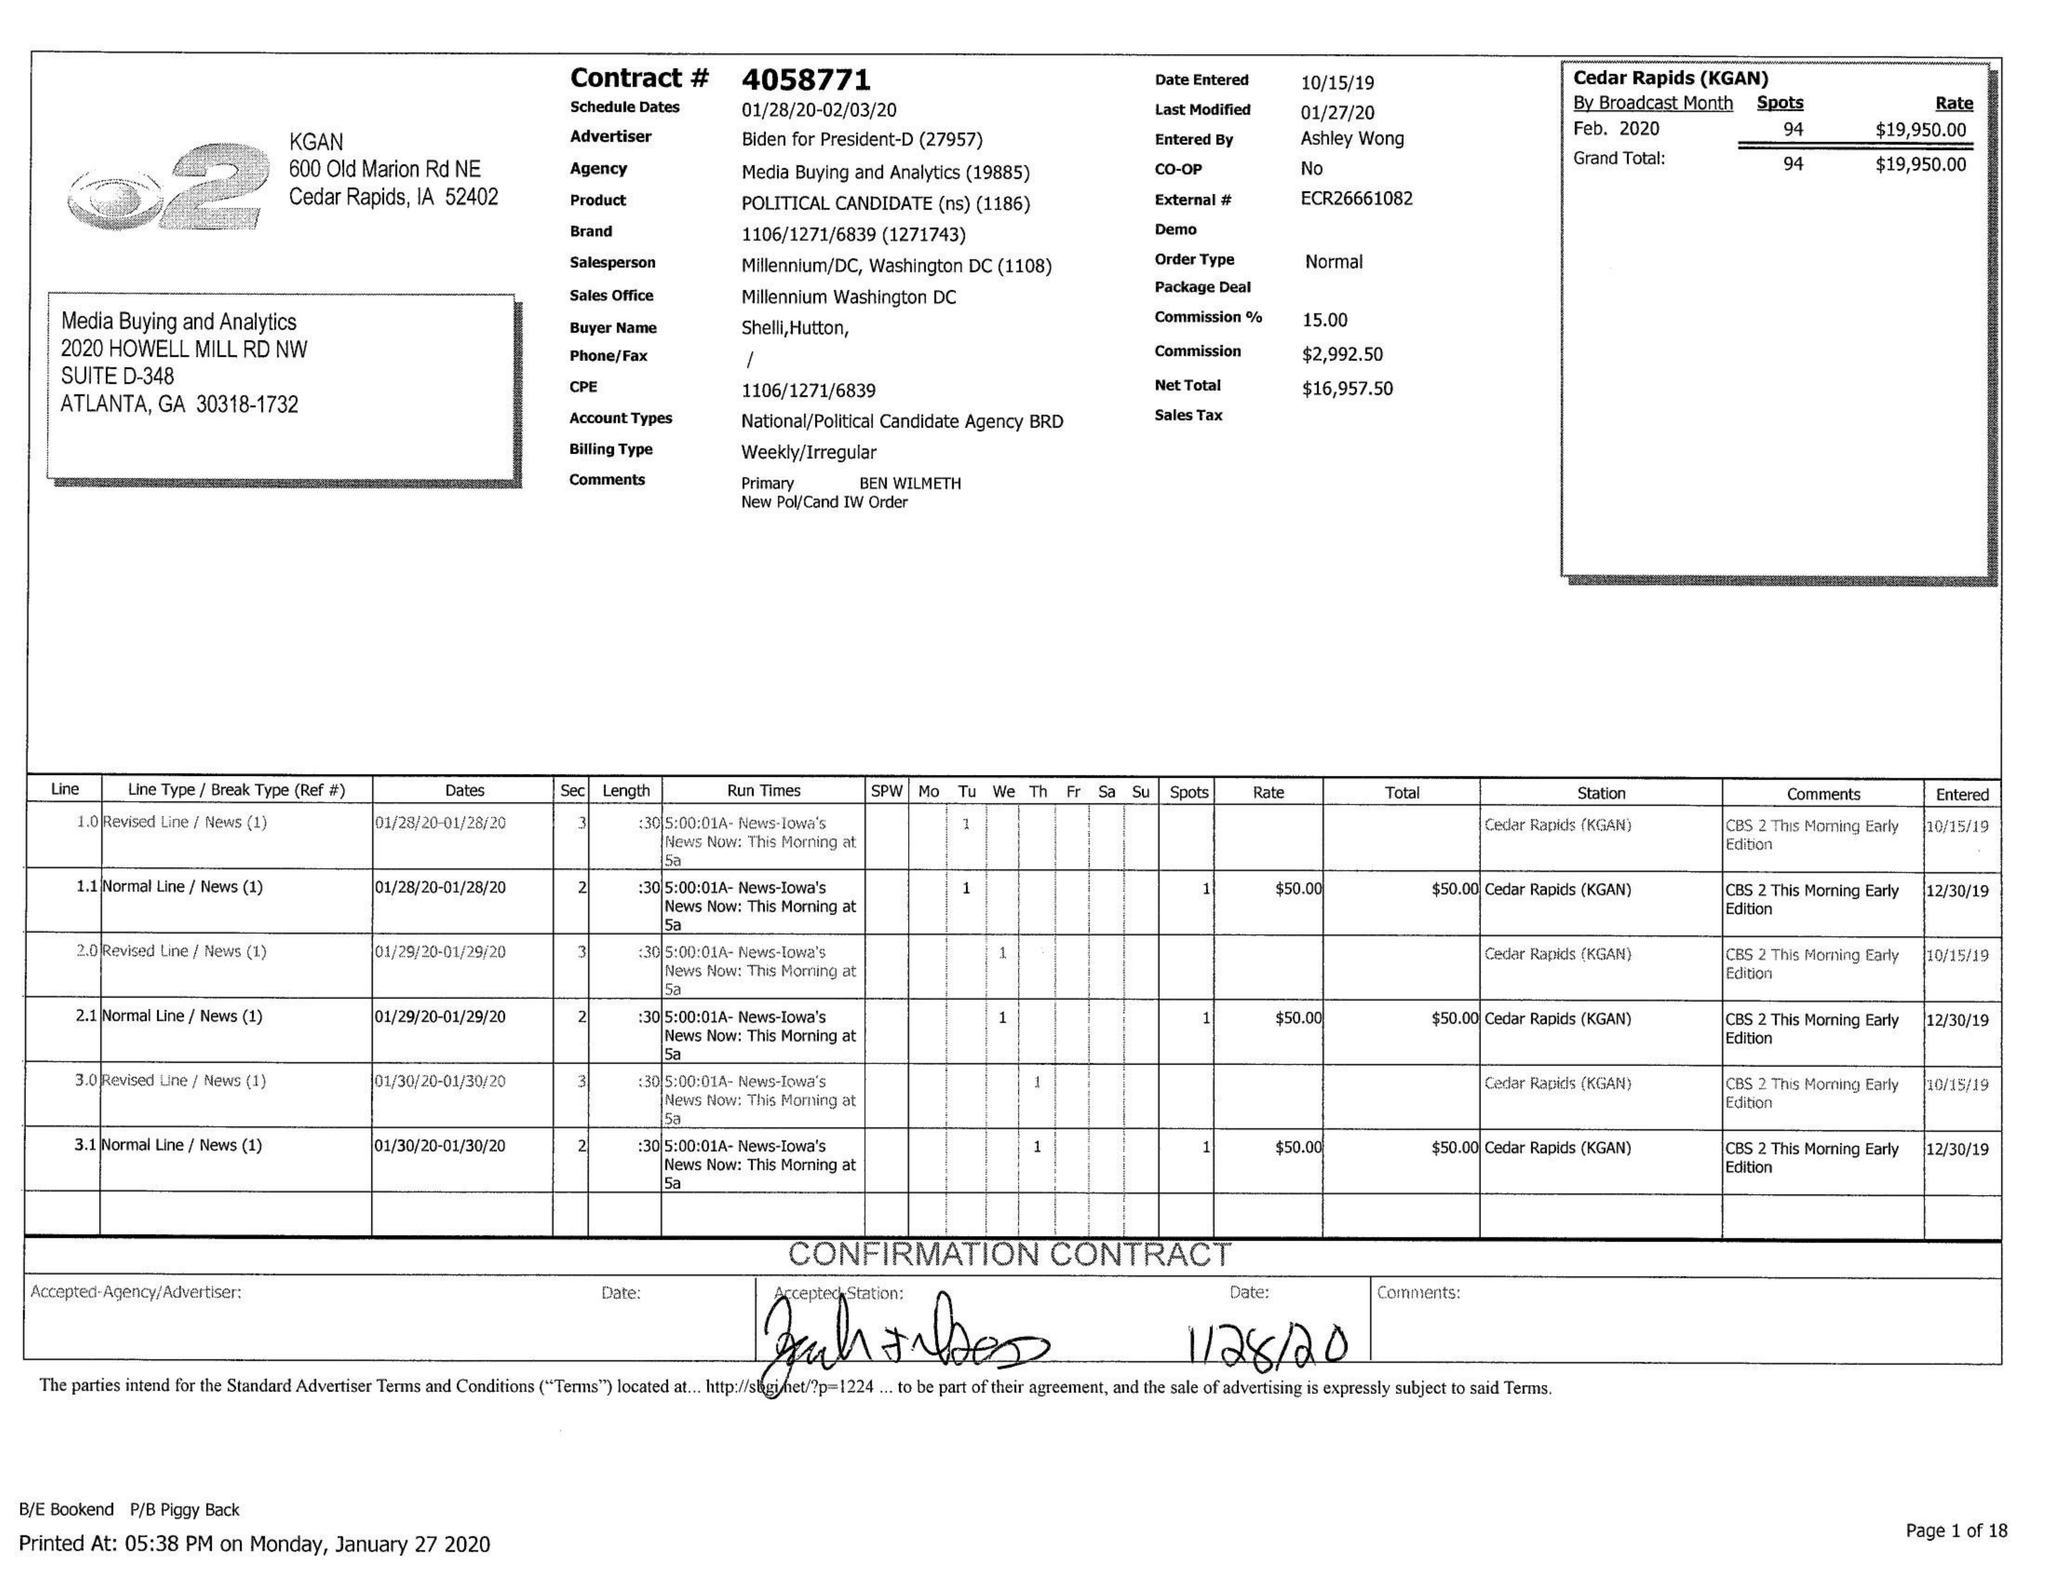What is the value for the flight_from?
Answer the question using a single word or phrase. 01/28/20 